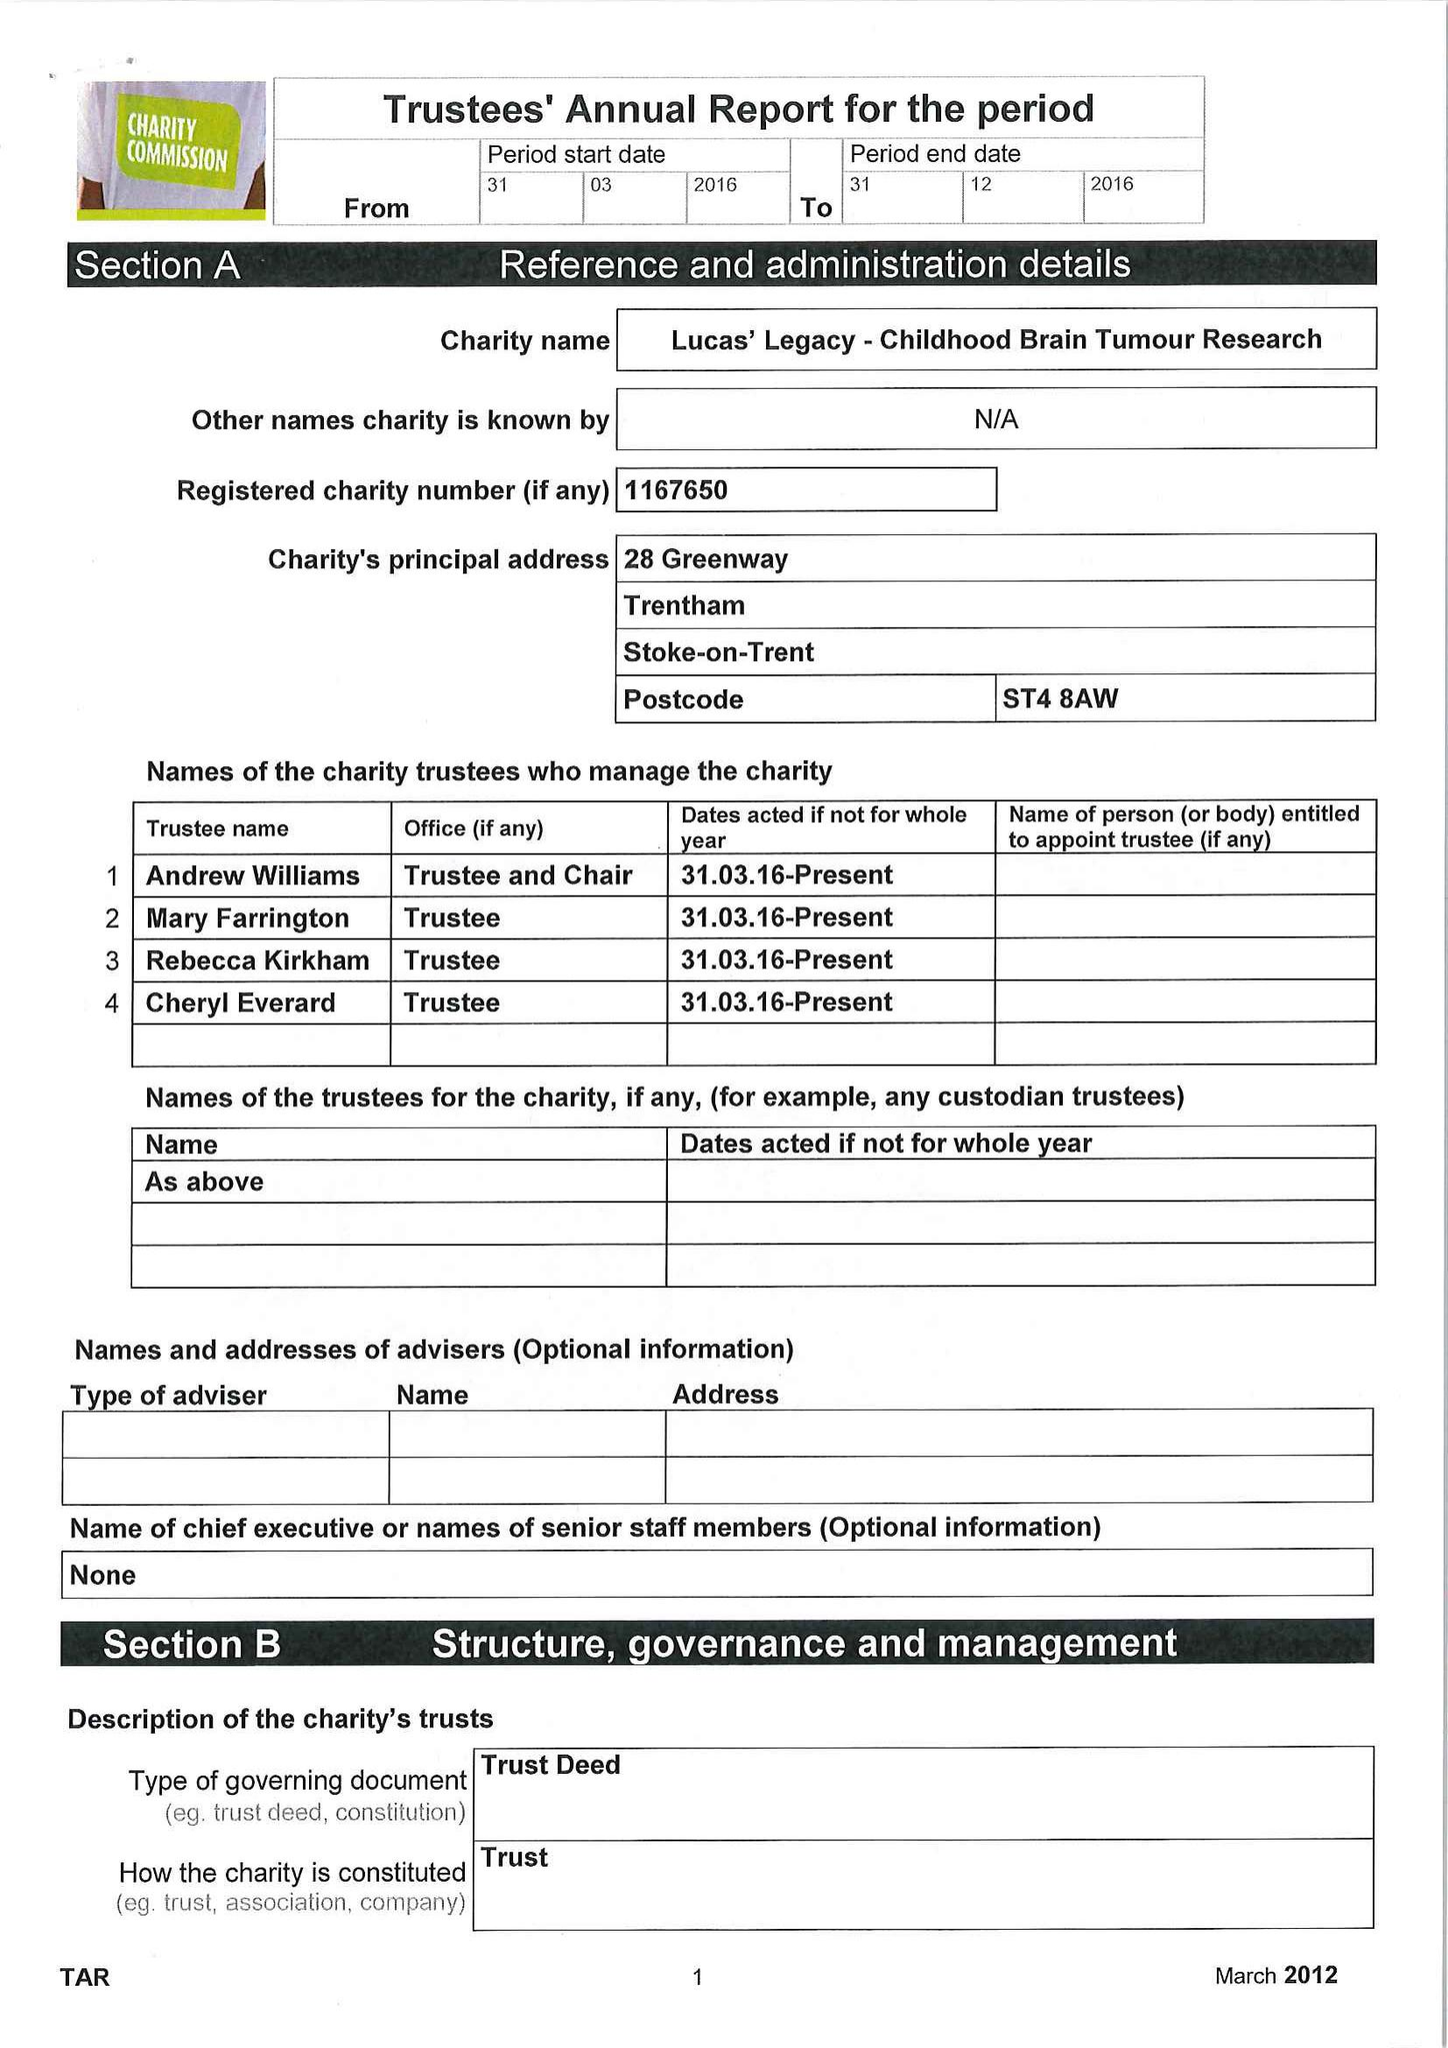What is the value for the charity_name?
Answer the question using a single word or phrase. Lucas' Legacy - Childhood Brain Tumour Research 